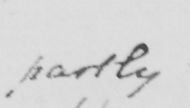Please provide the text content of this handwritten line. partly 